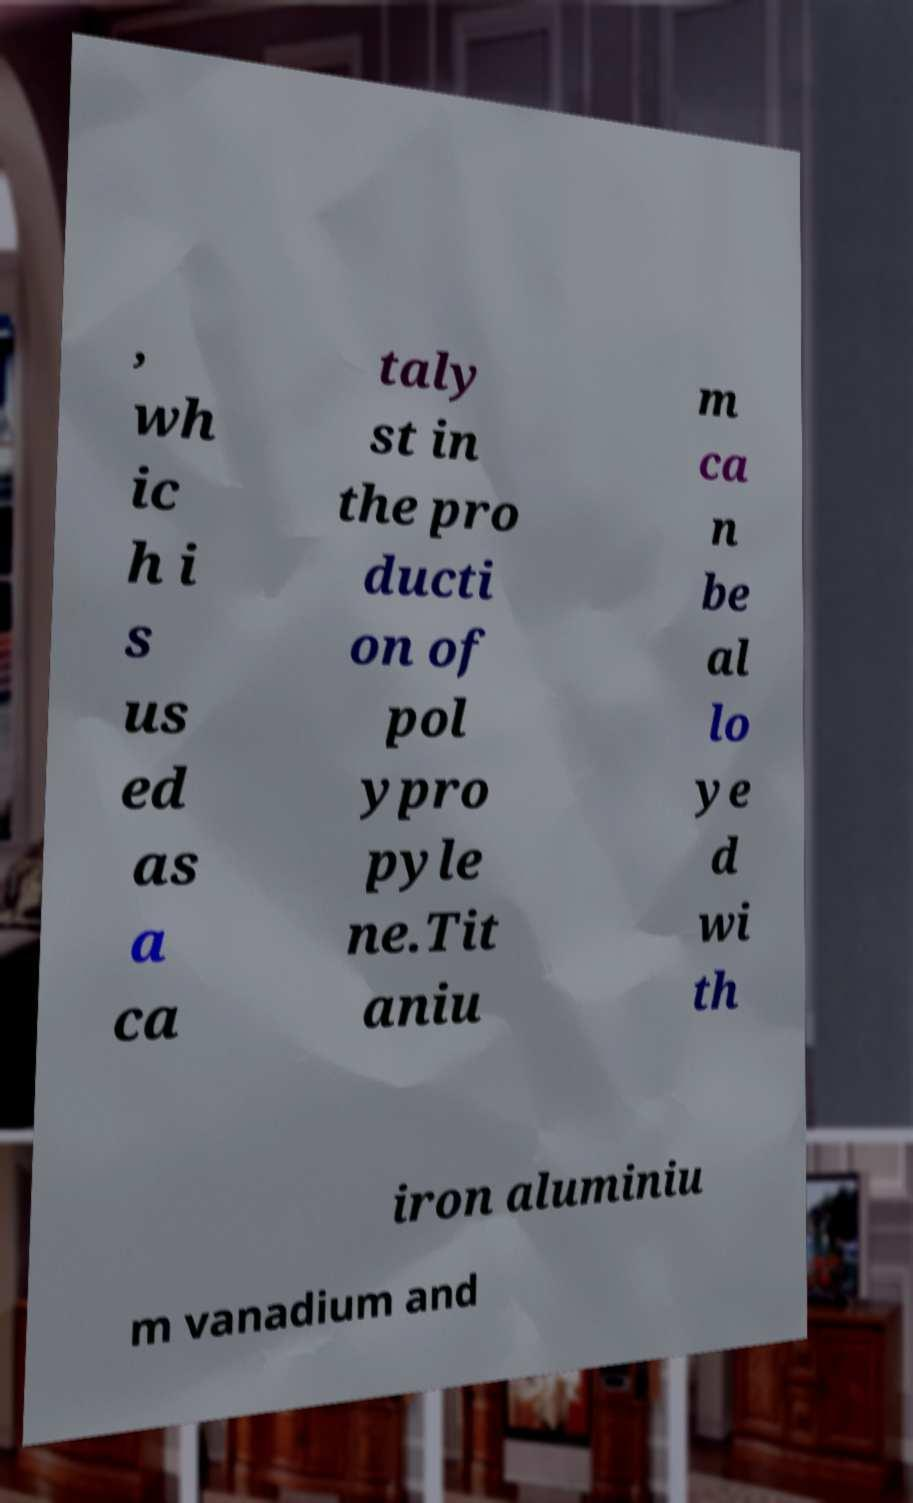What messages or text are displayed in this image? I need them in a readable, typed format. , wh ic h i s us ed as a ca taly st in the pro ducti on of pol ypro pyle ne.Tit aniu m ca n be al lo ye d wi th iron aluminiu m vanadium and 